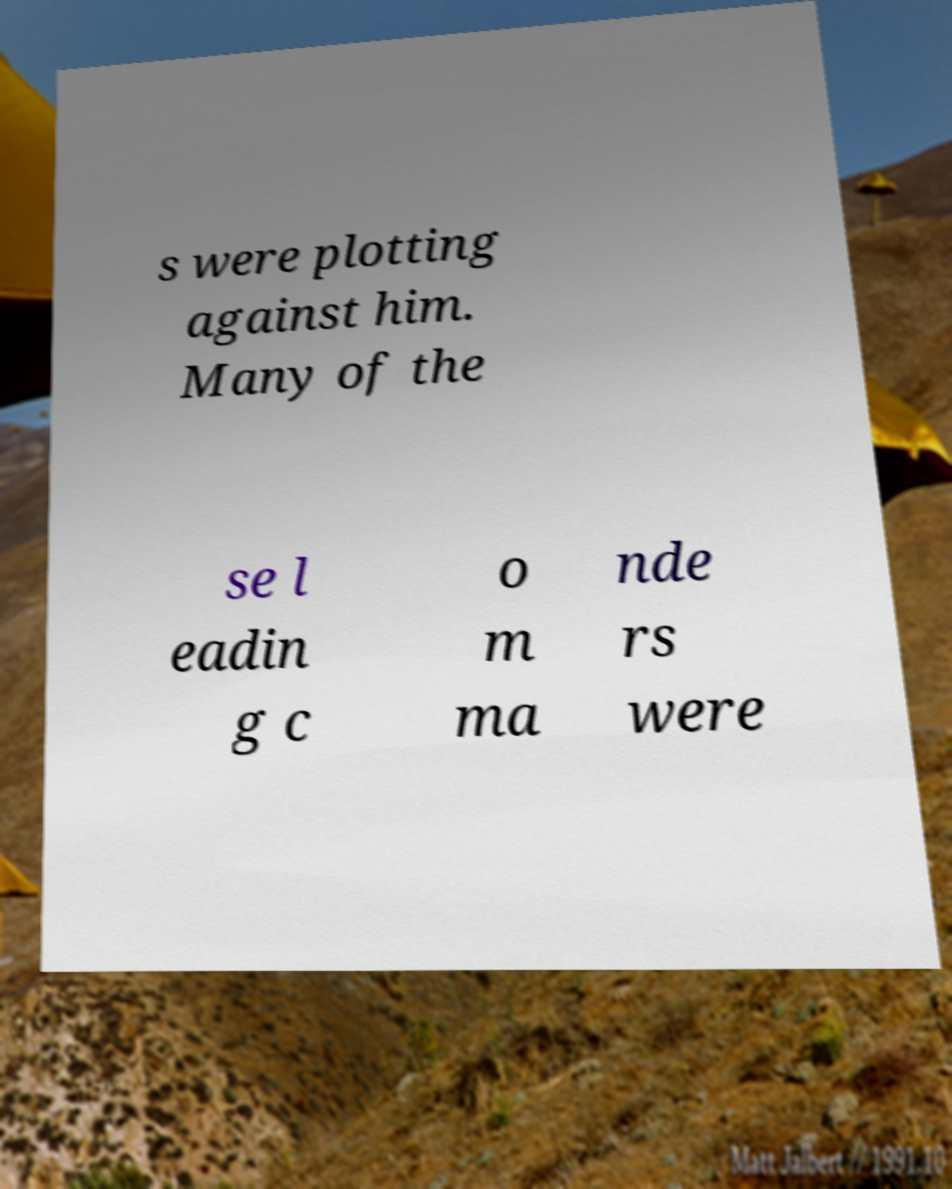What messages or text are displayed in this image? I need them in a readable, typed format. s were plotting against him. Many of the se l eadin g c o m ma nde rs were 